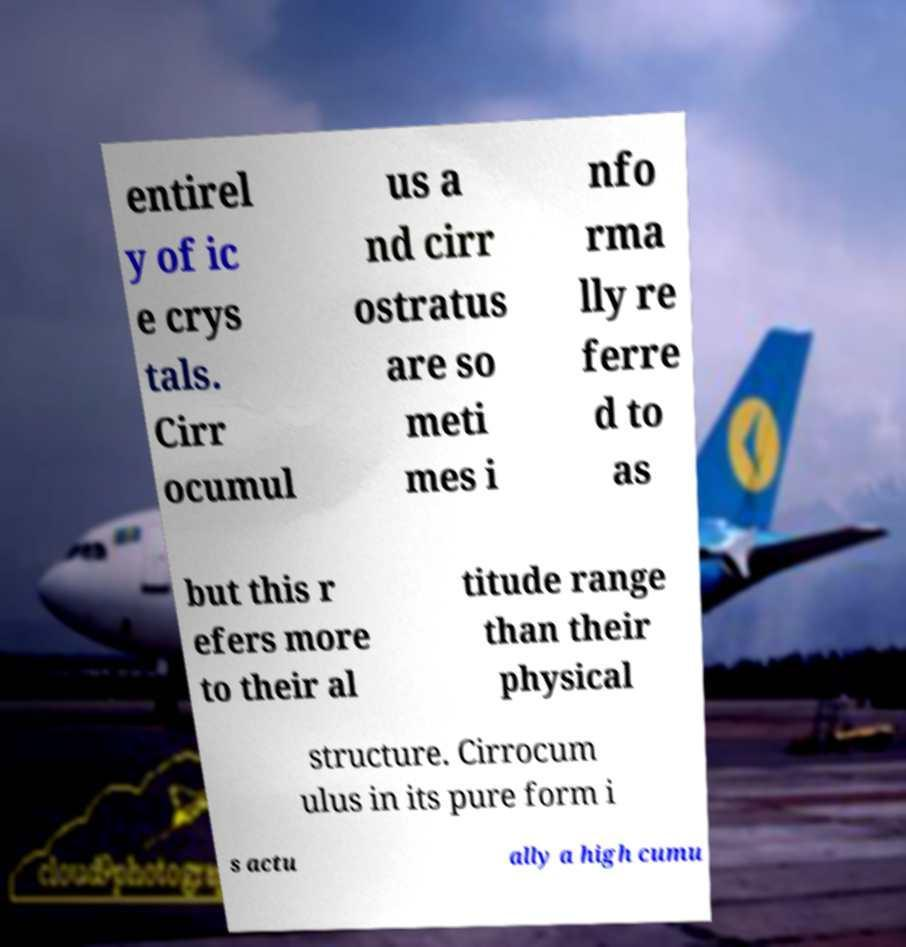What messages or text are displayed in this image? I need them in a readable, typed format. entirel y of ic e crys tals. Cirr ocumul us a nd cirr ostratus are so meti mes i nfo rma lly re ferre d to as but this r efers more to their al titude range than their physical structure. Cirrocum ulus in its pure form i s actu ally a high cumu 